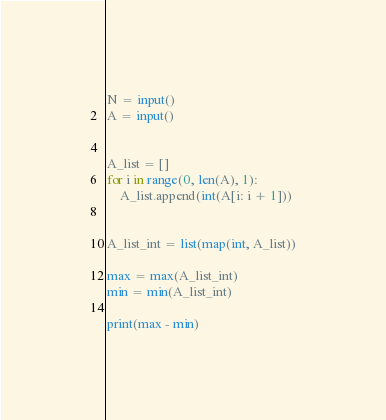<code> <loc_0><loc_0><loc_500><loc_500><_Python_>N = input()
A = input()


A_list = []
for i in range(0, len(A), 1):
    A_list.append(int(A[i: i + 1]))


A_list_int = list(map(int, A_list))

max = max(A_list_int)
min = min(A_list_int)

print(max - min)</code> 